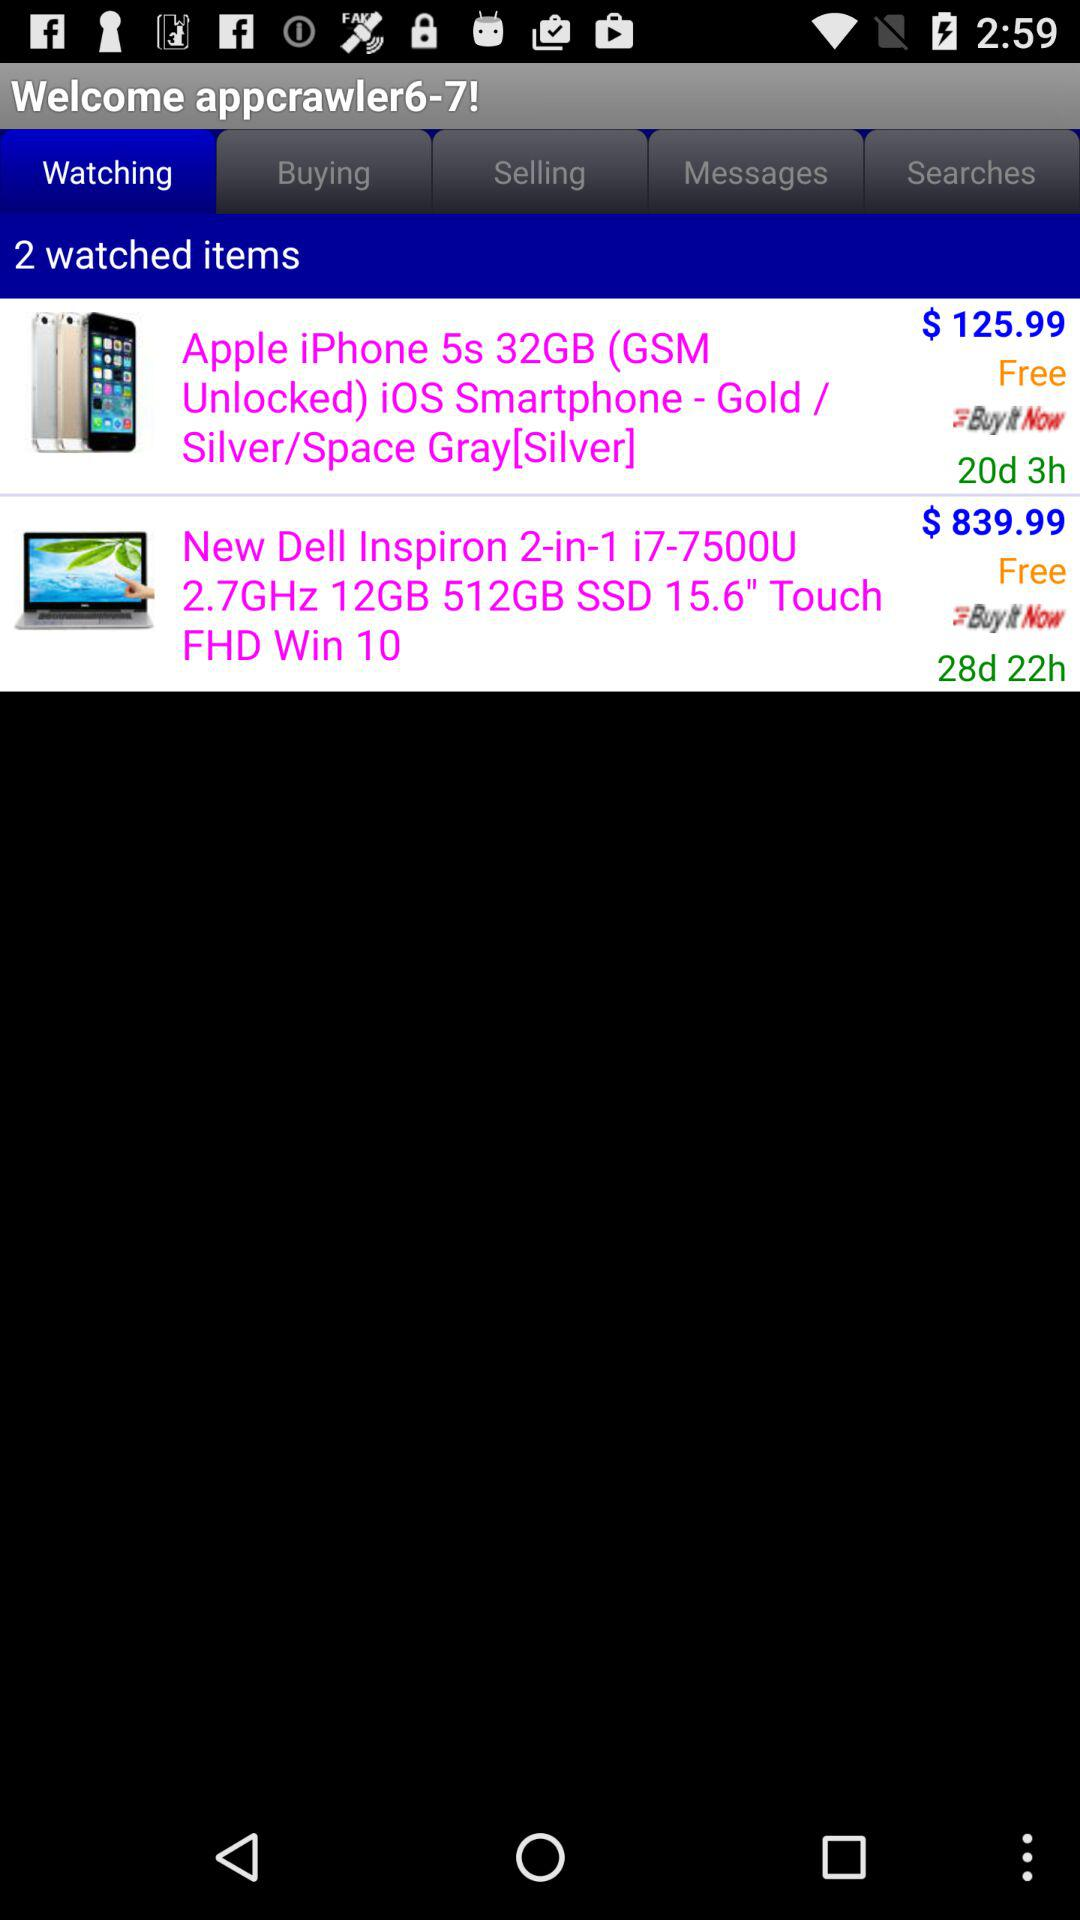What is the price of the Apple iPhone 5s? The price of the Apple iPhone 5s is $ 125.99. 